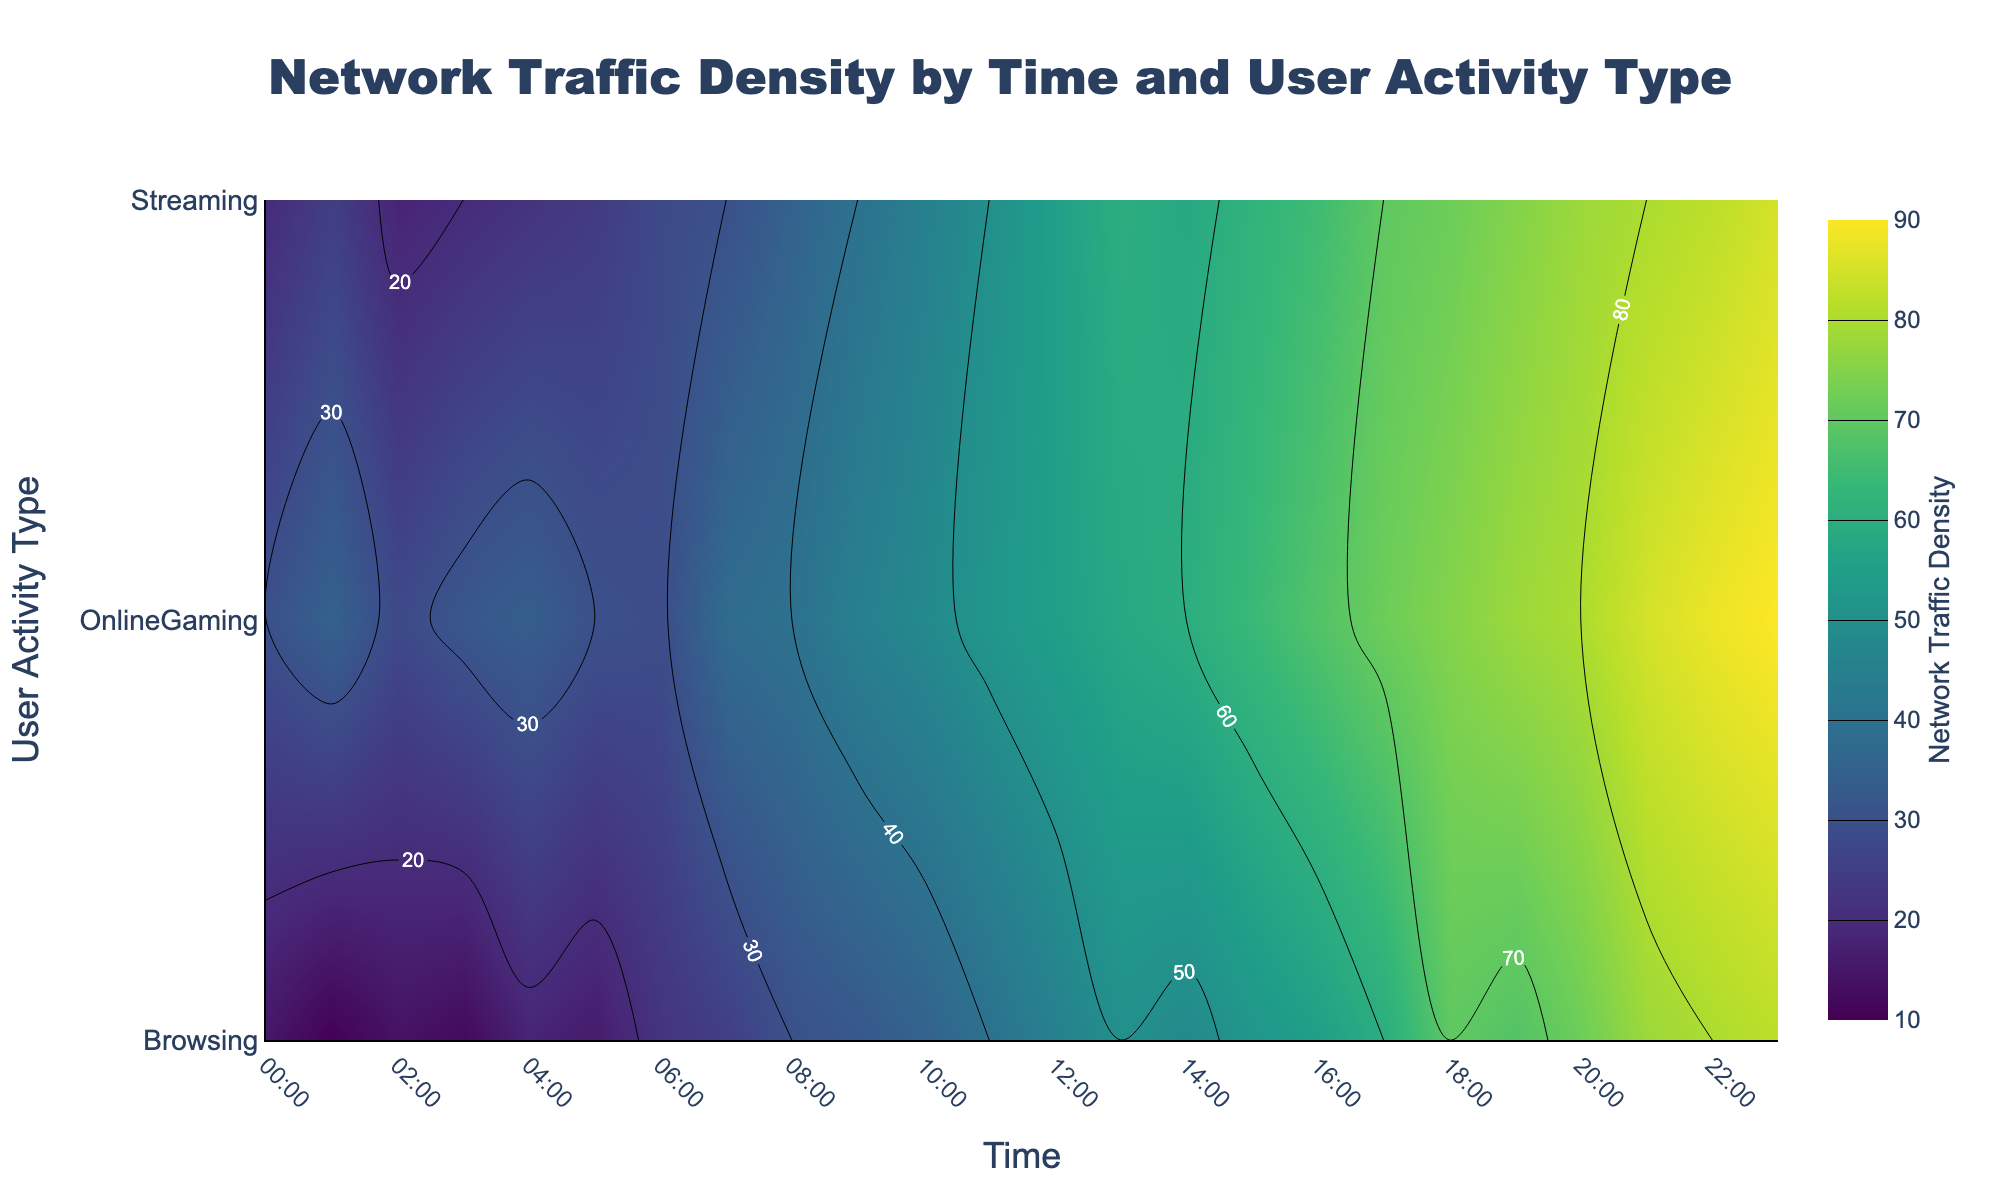what is the title of the figure? The title of the figure is usually displayed prominently on top and serves to describe the main subject of the plot. In this case, the title is "Network Traffic Density by Time and User Activity Type" as specified in the layout update section of the code.
Answer: Network Traffic Density by Time and User Activity Type what do the x and y axes represent? The x-axis title, located at the bottom, represents "Time" and the y-axis title, located on the left side, represents "User Activity Type". These titles are specified in the figure layout.
Answer: Time and User Activity Type what does a greenish color in the contour plot likely indicate? The colorscale 'Viridis' is used, where lower values tend to be in yellowish-green hues and transition to darker greens and purples for higher values. Thus, a greenish color would indicate moderate network traffic density.
Answer: Moderate network traffic density at which time is the network traffic density the highest for Streaming? By examining the contour plot, the highest traffic density for Streaming is marked by the darkest color. The specific time with the highest density is around 23:00 as observed from the plot.
Answer: 23:00 compare the network traffic densities of Browsing and OnlineGaming at 12:00. Which activity has greater density? At 12:00, check the contour plot for the density values for both Browsing and OnlineGaming. Browsing density is around 45, while OnlineGaming is around 55. Thus, OnlineGaming has a greater density.
Answer: OnlineGaming how does the network traffic density for Browsing change between 06:00 and 18:00? To understand the change in network traffic density for Browsing between 06:00 and 18:00, observe the trend line in the contour plot from 06:00 to 18:00. The density increases from 22 at 06:00 to 70 at 18:00, indicating an upward trend.
Answer: It increases during which time period is OnlineGaming the most active? The most active period for OnlineGaming is indicated by the darkest regions in the contour plot under the OnlineGaming activity. This period is around 21:00 to 23:00.
Answer: 21:00 to 23:00 if the traffic densities for Streaming at 10:00 and 15:00 are combined, what is the total density? According to the contour plot, note the traffic densities for Streaming at 10:00 and 15:00. Adding these values, 45 at 10:00 and 62 at 15:00, gives a total of 107.
Answer: 107 which user activity type shows the least change in network traffic density throughout the entire day? Observe the contour lines for each activity type. Browsing shows relatively smoother and less varied changes compared to Streaming and OnlineGaming, indicating the least change over the day.
Answer: Browsing 